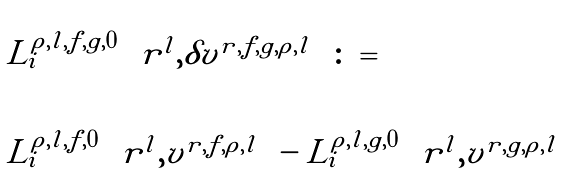Convert formula to latex. <formula><loc_0><loc_0><loc_500><loc_500>\begin{array} { l l } L ^ { \rho , l , f , g , 0 } _ { i } \left ( r ^ { l } , \delta v ^ { r , f , g , \rho , l } \right ) \colon = \\ \\ L ^ { \rho , l , f , 0 } _ { i } \left ( r ^ { l } , v ^ { r , f , \rho , l } \right ) - L ^ { \rho , l , g , 0 } _ { i } \left ( r ^ { l } , v ^ { r , g , \rho , l } \right ) \end{array}</formula> 